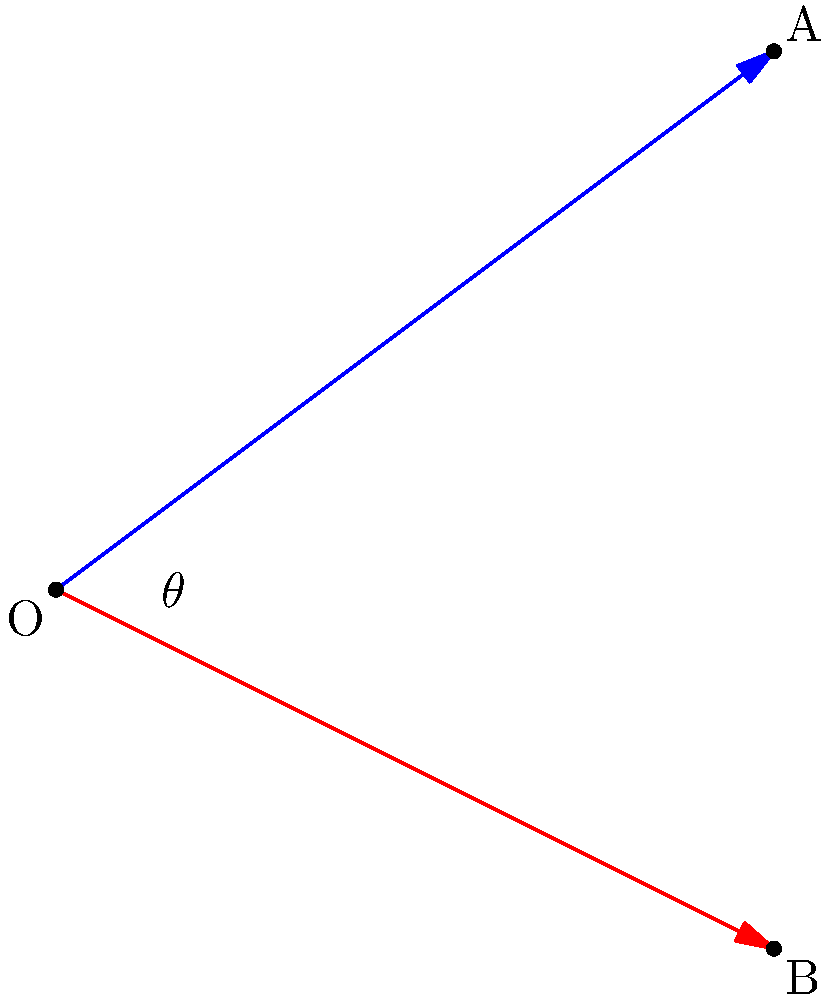In a comic book panel, two laser beams are depicted intersecting at the origin O(0,0). The blue beam terminates at point A(4,3), while the red beam ends at point B(4,-2). What is the angle $\theta$ between these two laser beams? To find the angle between the two laser beams, we can use the dot product formula:

1) First, let's define the vectors $\vec{OA}$ and $\vec{OB}$:
   $\vec{OA} = (4,3)$ and $\vec{OB} = (4,-2)$

2) The dot product formula states:
   $\cos \theta = \frac{\vec{OA} \cdot \vec{OB}}{|\vec{OA}||\vec{OB}|}$

3) Calculate the dot product $\vec{OA} \cdot \vec{OB}$:
   $\vec{OA} \cdot \vec{OB} = (4)(4) + (3)(-2) = 16 - 6 = 10$

4) Calculate the magnitudes:
   $|\vec{OA}| = \sqrt{4^2 + 3^2} = \sqrt{25} = 5$
   $|\vec{OB}| = \sqrt{4^2 + (-2)^2} = \sqrt{20} = 2\sqrt{5}$

5) Substitute into the formula:
   $\cos \theta = \frac{10}{5(2\sqrt{5})} = \frac{1}{\sqrt{5}}$

6) Take the inverse cosine (arccos) of both sides:
   $\theta = \arccos(\frac{1}{\sqrt{5}})$

7) Calculate the result:
   $\theta \approx 1.1071$ radians or $63.4349$ degrees
Answer: $\theta = \arccos(\frac{1}{\sqrt{5}}) \approx 63.4°$ 